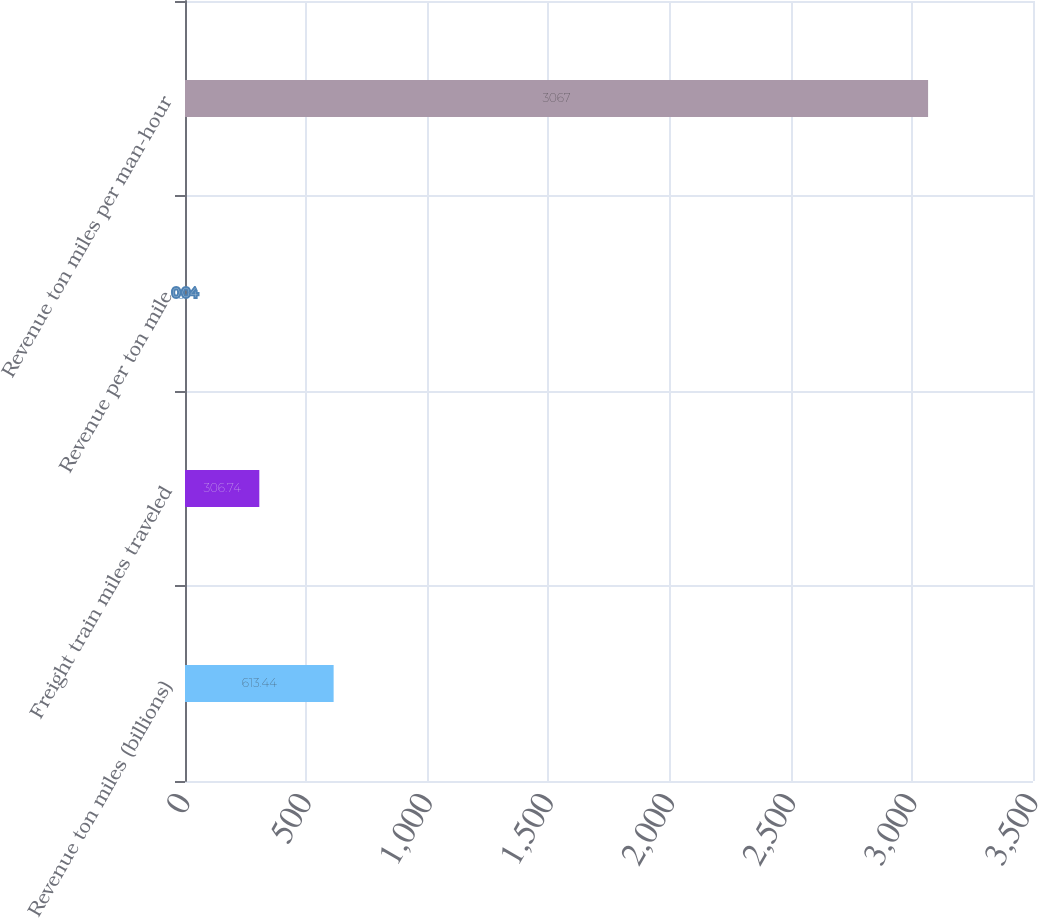Convert chart to OTSL. <chart><loc_0><loc_0><loc_500><loc_500><bar_chart><fcel>Revenue ton miles (billions)<fcel>Freight train miles traveled<fcel>Revenue per ton mile<fcel>Revenue ton miles per man-hour<nl><fcel>613.44<fcel>306.74<fcel>0.04<fcel>3067<nl></chart> 